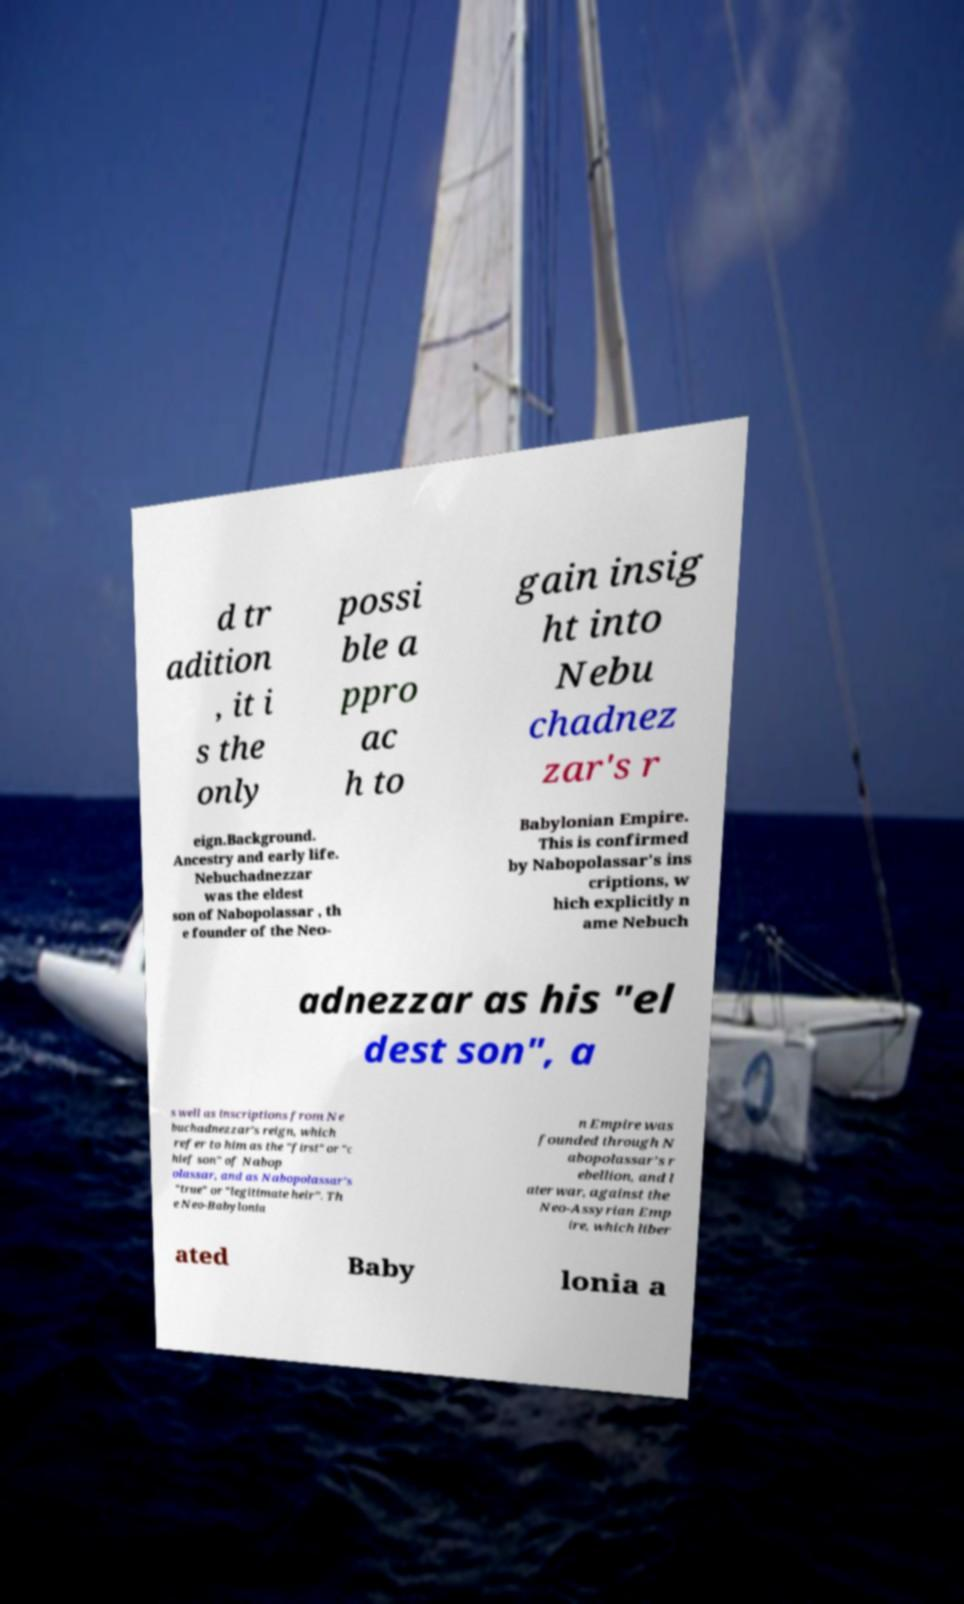Could you assist in decoding the text presented in this image and type it out clearly? d tr adition , it i s the only possi ble a ppro ac h to gain insig ht into Nebu chadnez zar's r eign.Background. Ancestry and early life. Nebuchadnezzar was the eldest son of Nabopolassar , th e founder of the Neo- Babylonian Empire. This is confirmed by Nabopolassar's ins criptions, w hich explicitly n ame Nebuch adnezzar as his "el dest son", a s well as inscriptions from Ne buchadnezzar's reign, which refer to him as the "first" or "c hief son" of Nabop olassar, and as Nabopolassar's "true" or "legitimate heir". Th e Neo-Babylonia n Empire was founded through N abopolassar's r ebellion, and l ater war, against the Neo-Assyrian Emp ire, which liber ated Baby lonia a 